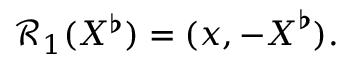Convert formula to latex. <formula><loc_0><loc_0><loc_500><loc_500>\mathcal { R } _ { 1 } ( X ^ { \flat } ) = ( x , - X ^ { \flat } ) .</formula> 